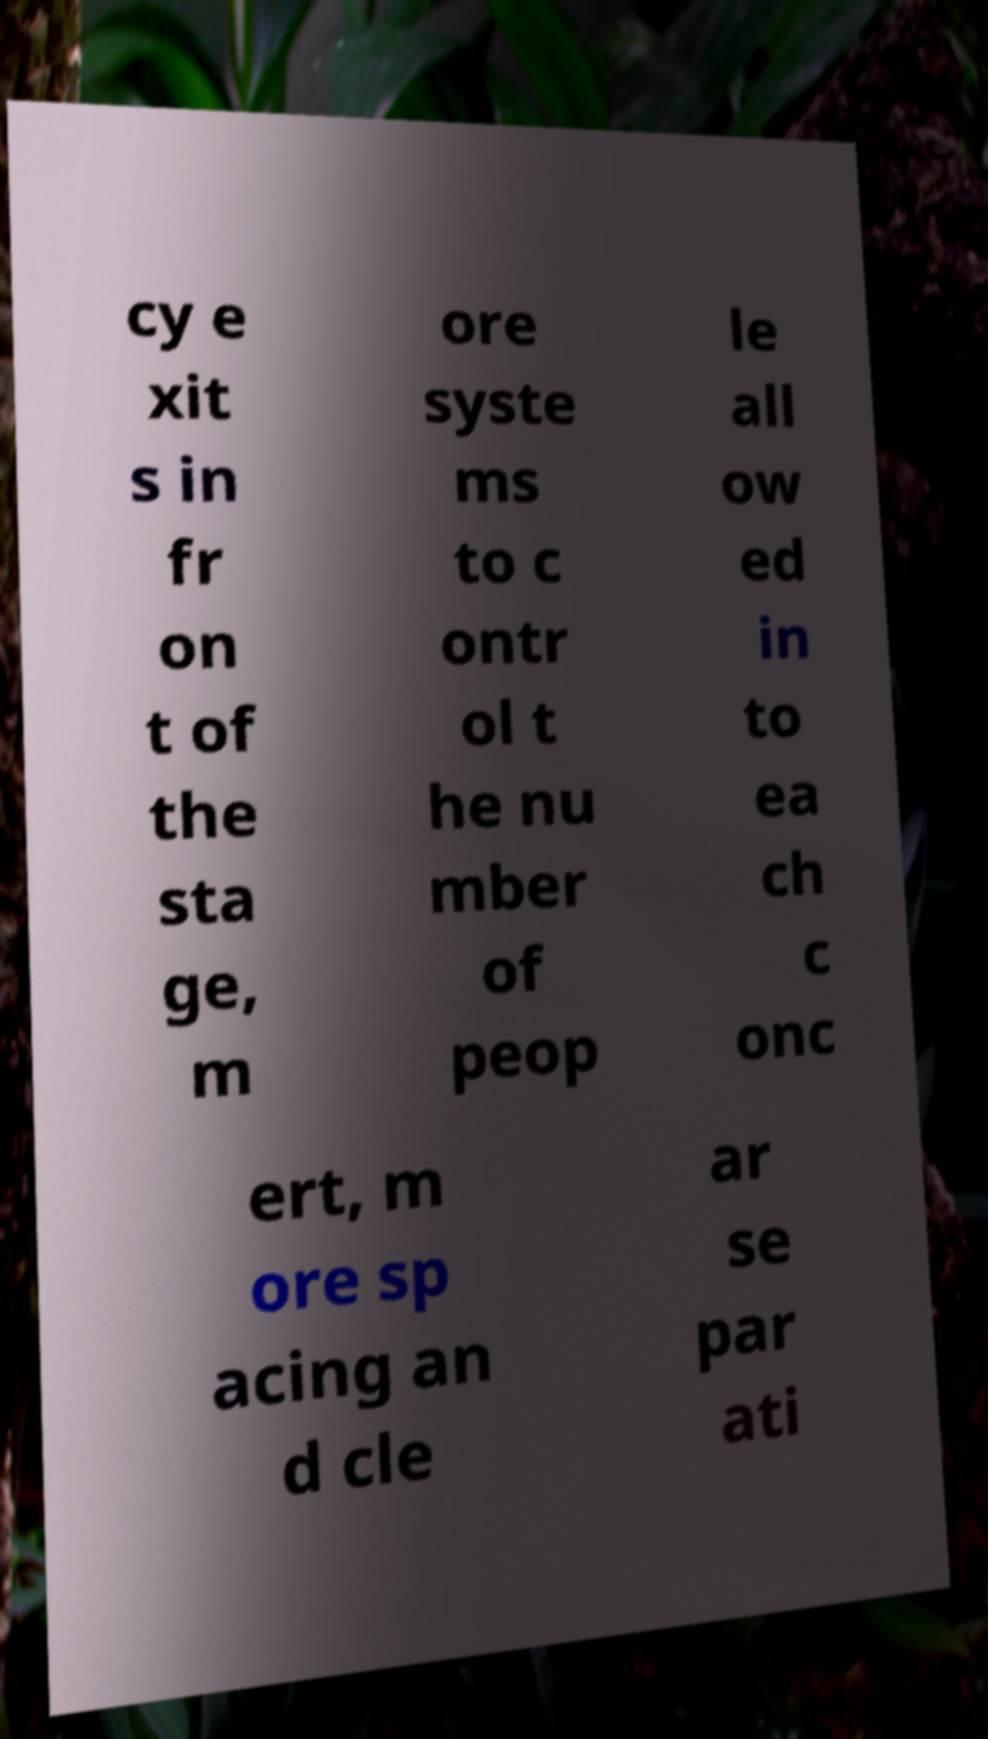I need the written content from this picture converted into text. Can you do that? cy e xit s in fr on t of the sta ge, m ore syste ms to c ontr ol t he nu mber of peop le all ow ed in to ea ch c onc ert, m ore sp acing an d cle ar se par ati 